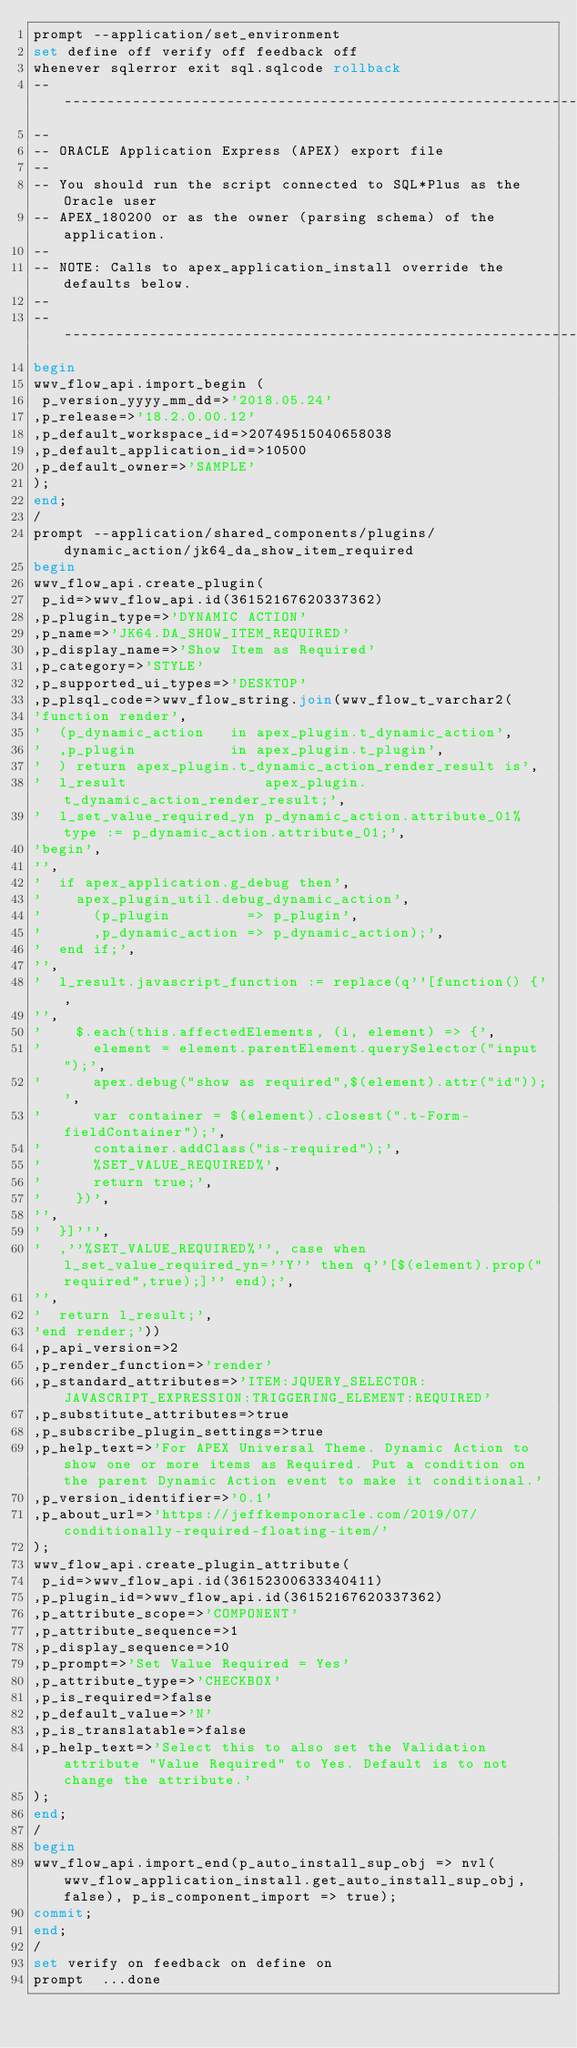Convert code to text. <code><loc_0><loc_0><loc_500><loc_500><_SQL_>prompt --application/set_environment
set define off verify off feedback off
whenever sqlerror exit sql.sqlcode rollback
--------------------------------------------------------------------------------
--
-- ORACLE Application Express (APEX) export file
--
-- You should run the script connected to SQL*Plus as the Oracle user
-- APEX_180200 or as the owner (parsing schema) of the application.
--
-- NOTE: Calls to apex_application_install override the defaults below.
--
--------------------------------------------------------------------------------
begin
wwv_flow_api.import_begin (
 p_version_yyyy_mm_dd=>'2018.05.24'
,p_release=>'18.2.0.00.12'
,p_default_workspace_id=>20749515040658038
,p_default_application_id=>10500
,p_default_owner=>'SAMPLE'
);
end;
/
prompt --application/shared_components/plugins/dynamic_action/jk64_da_show_item_required
begin
wwv_flow_api.create_plugin(
 p_id=>wwv_flow_api.id(36152167620337362)
,p_plugin_type=>'DYNAMIC ACTION'
,p_name=>'JK64.DA_SHOW_ITEM_REQUIRED'
,p_display_name=>'Show Item as Required'
,p_category=>'STYLE'
,p_supported_ui_types=>'DESKTOP'
,p_plsql_code=>wwv_flow_string.join(wwv_flow_t_varchar2(
'function render',
'  (p_dynamic_action   in apex_plugin.t_dynamic_action',
'  ,p_plugin           in apex_plugin.t_plugin',
'  ) return apex_plugin.t_dynamic_action_render_result is',
'  l_result                apex_plugin.t_dynamic_action_render_result;',
'  l_set_value_required_yn p_dynamic_action.attribute_01%type := p_dynamic_action.attribute_01;',
'begin',
'',
'  if apex_application.g_debug then',
'    apex_plugin_util.debug_dynamic_action',
'      (p_plugin         => p_plugin',
'      ,p_dynamic_action => p_dynamic_action);',
'  end if;',
'',
'  l_result.javascript_function := replace(q''[function() {',
'',
'    $.each(this.affectedElements, (i, element) => {',
'      element = element.parentElement.querySelector("input");',
'      apex.debug("show as required",$(element).attr("id"));',
'      var container = $(element).closest(".t-Form-fieldContainer");',
'      container.addClass("is-required");',
'      %SET_VALUE_REQUIRED%',
'      return true;',
'    })',
'',
'  }]''',
'  ,''%SET_VALUE_REQUIRED%'', case when l_set_value_required_yn=''Y'' then q''[$(element).prop("required",true);]'' end);',
'',
'  return l_result;',
'end render;'))
,p_api_version=>2
,p_render_function=>'render'
,p_standard_attributes=>'ITEM:JQUERY_SELECTOR:JAVASCRIPT_EXPRESSION:TRIGGERING_ELEMENT:REQUIRED'
,p_substitute_attributes=>true
,p_subscribe_plugin_settings=>true
,p_help_text=>'For APEX Universal Theme. Dynamic Action to show one or more items as Required. Put a condition on the parent Dynamic Action event to make it conditional.'
,p_version_identifier=>'0.1'
,p_about_url=>'https://jeffkemponoracle.com/2019/07/conditionally-required-floating-item/'
);
wwv_flow_api.create_plugin_attribute(
 p_id=>wwv_flow_api.id(36152300633340411)
,p_plugin_id=>wwv_flow_api.id(36152167620337362)
,p_attribute_scope=>'COMPONENT'
,p_attribute_sequence=>1
,p_display_sequence=>10
,p_prompt=>'Set Value Required = Yes'
,p_attribute_type=>'CHECKBOX'
,p_is_required=>false
,p_default_value=>'N'
,p_is_translatable=>false
,p_help_text=>'Select this to also set the Validation attribute "Value Required" to Yes. Default is to not change the attribute.'
);
end;
/
begin
wwv_flow_api.import_end(p_auto_install_sup_obj => nvl(wwv_flow_application_install.get_auto_install_sup_obj, false), p_is_component_import => true);
commit;
end;
/
set verify on feedback on define on
prompt  ...done
</code> 